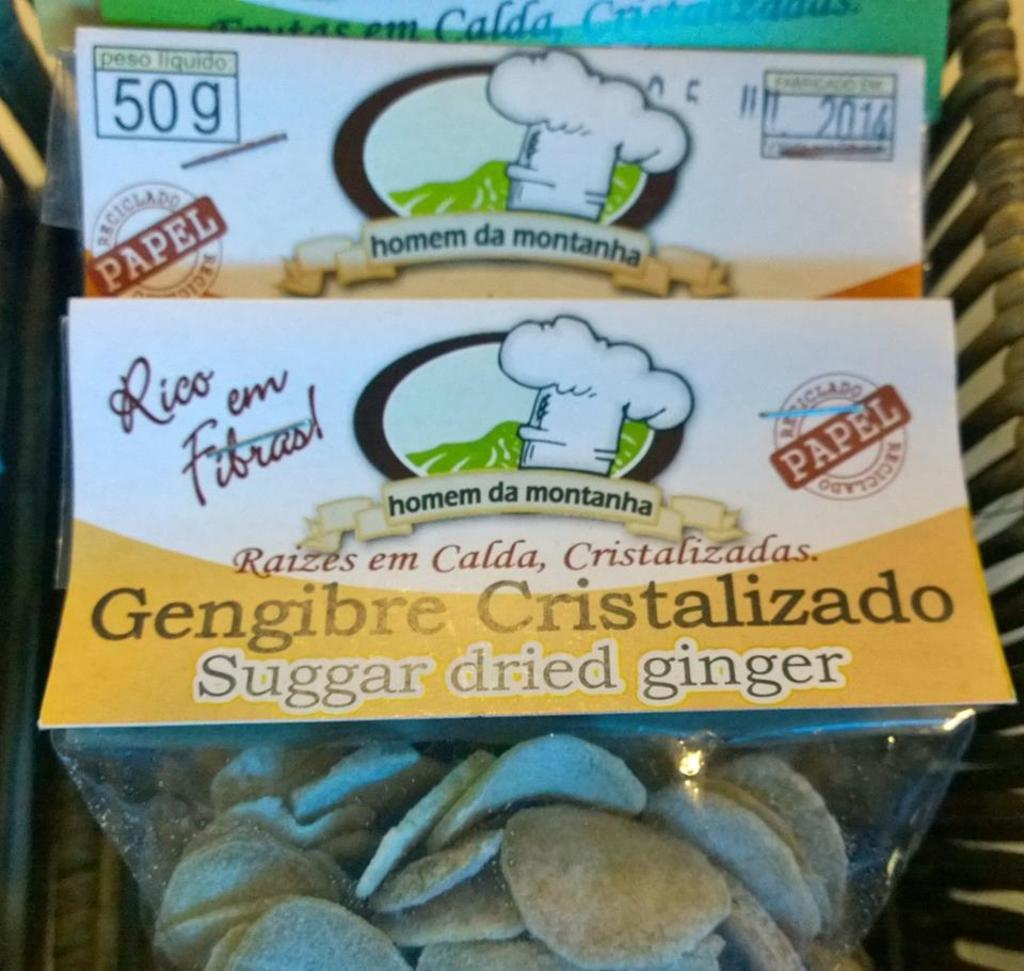What can be observed in the image? There are items placed in the image. How can the items be identified? The items have labels containing images and text. How many deer are visible in the image? There are no deer present in the image. What type of orange is being used as a label on the items? There is no orange being used as a label on the items; the labels contain images and text. 